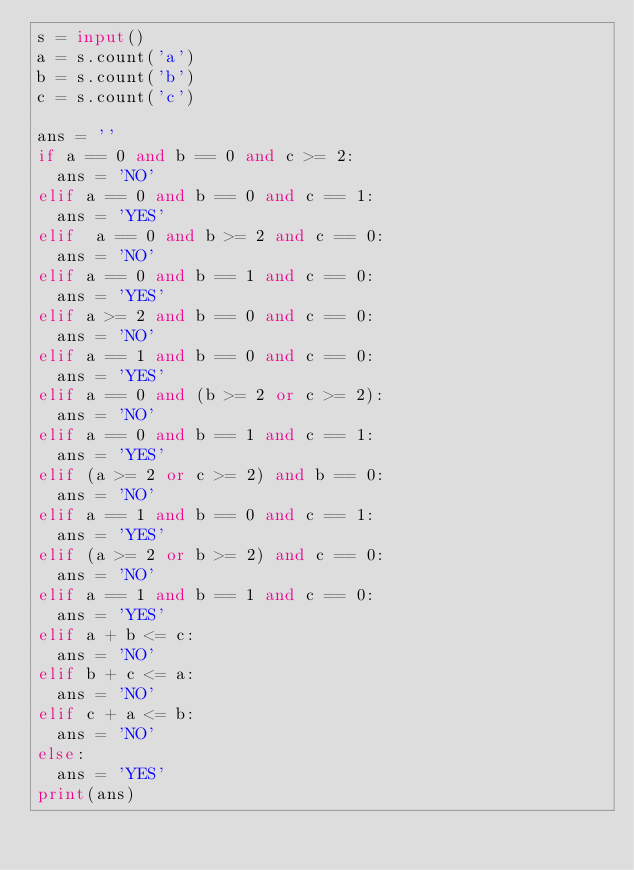<code> <loc_0><loc_0><loc_500><loc_500><_Python_>s = input()
a = s.count('a')
b = s.count('b')
c = s.count('c')

ans = ''
if a == 0 and b == 0 and c >= 2:
  ans = 'NO'
elif a == 0 and b == 0 and c == 1:
  ans = 'YES'
elif  a == 0 and b >= 2 and c == 0:
  ans = 'NO'
elif a == 0 and b == 1 and c == 0:
  ans = 'YES'
elif a >= 2 and b == 0 and c == 0:
  ans = 'NO'
elif a == 1 and b == 0 and c == 0:
  ans = 'YES'
elif a == 0 and (b >= 2 or c >= 2):
  ans = 'NO'
elif a == 0 and b == 1 and c == 1:
  ans = 'YES'
elif (a >= 2 or c >= 2) and b == 0:
  ans = 'NO'
elif a == 1 and b == 0 and c == 1:
  ans = 'YES'
elif (a >= 2 or b >= 2) and c == 0:
  ans = 'NO'
elif a == 1 and b == 1 and c == 0:
  ans = 'YES'
elif a + b <= c:
  ans = 'NO'
elif b + c <= a:
  ans = 'NO'
elif c + a <= b:
  ans = 'NO'
else:
  ans = 'YES'
print(ans)</code> 